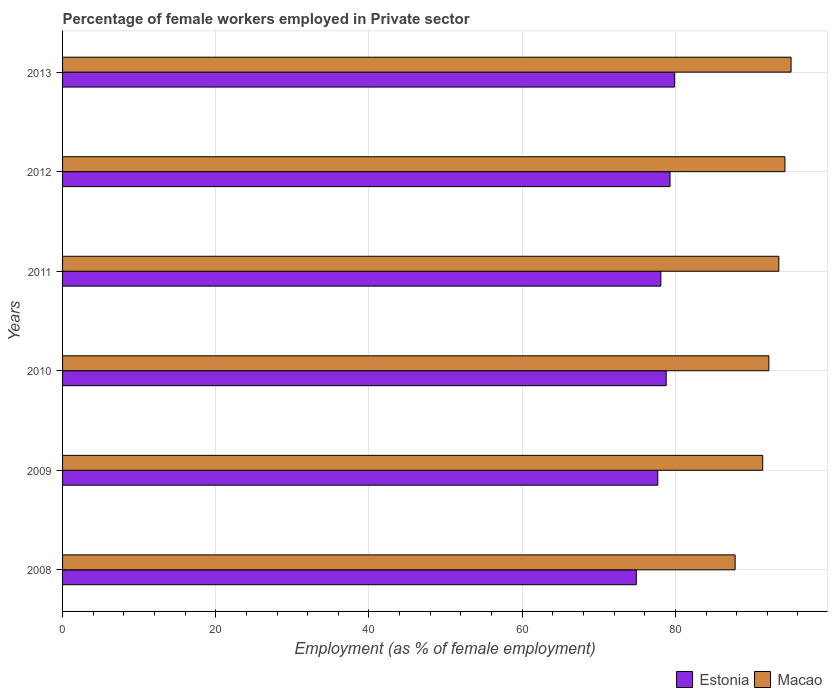How many different coloured bars are there?
Your answer should be compact. 2. Are the number of bars per tick equal to the number of legend labels?
Offer a very short reply. Yes. Are the number of bars on each tick of the Y-axis equal?
Provide a succinct answer. Yes. In how many cases, is the number of bars for a given year not equal to the number of legend labels?
Give a very brief answer. 0. What is the percentage of females employed in Private sector in Estonia in 2011?
Make the answer very short. 78.1. Across all years, what is the maximum percentage of females employed in Private sector in Estonia?
Provide a succinct answer. 79.9. Across all years, what is the minimum percentage of females employed in Private sector in Macao?
Keep it short and to the point. 87.8. In which year was the percentage of females employed in Private sector in Estonia maximum?
Your answer should be compact. 2013. What is the total percentage of females employed in Private sector in Macao in the graph?
Your answer should be very brief. 554.3. What is the difference between the percentage of females employed in Private sector in Estonia in 2009 and that in 2011?
Provide a succinct answer. -0.4. What is the difference between the percentage of females employed in Private sector in Estonia in 2013 and the percentage of females employed in Private sector in Macao in 2012?
Your answer should be very brief. -14.4. What is the average percentage of females employed in Private sector in Estonia per year?
Give a very brief answer. 78.12. In the year 2011, what is the difference between the percentage of females employed in Private sector in Macao and percentage of females employed in Private sector in Estonia?
Offer a terse response. 15.4. In how many years, is the percentage of females employed in Private sector in Macao greater than 28 %?
Provide a short and direct response. 6. What is the ratio of the percentage of females employed in Private sector in Macao in 2008 to that in 2011?
Provide a succinct answer. 0.94. What is the difference between the highest and the second highest percentage of females employed in Private sector in Estonia?
Offer a terse response. 0.6. What is the difference between the highest and the lowest percentage of females employed in Private sector in Estonia?
Your answer should be very brief. 5. In how many years, is the percentage of females employed in Private sector in Macao greater than the average percentage of females employed in Private sector in Macao taken over all years?
Your response must be concise. 3. Is the sum of the percentage of females employed in Private sector in Estonia in 2008 and 2009 greater than the maximum percentage of females employed in Private sector in Macao across all years?
Offer a very short reply. Yes. What does the 1st bar from the top in 2011 represents?
Your answer should be compact. Macao. What does the 1st bar from the bottom in 2009 represents?
Make the answer very short. Estonia. How many bars are there?
Make the answer very short. 12. Are all the bars in the graph horizontal?
Your response must be concise. Yes. What is the difference between two consecutive major ticks on the X-axis?
Offer a very short reply. 20. Does the graph contain grids?
Your answer should be very brief. Yes. What is the title of the graph?
Your response must be concise. Percentage of female workers employed in Private sector. What is the label or title of the X-axis?
Keep it short and to the point. Employment (as % of female employment). What is the Employment (as % of female employment) in Estonia in 2008?
Make the answer very short. 74.9. What is the Employment (as % of female employment) in Macao in 2008?
Offer a very short reply. 87.8. What is the Employment (as % of female employment) of Estonia in 2009?
Offer a terse response. 77.7. What is the Employment (as % of female employment) in Macao in 2009?
Ensure brevity in your answer.  91.4. What is the Employment (as % of female employment) of Estonia in 2010?
Ensure brevity in your answer.  78.8. What is the Employment (as % of female employment) in Macao in 2010?
Offer a terse response. 92.2. What is the Employment (as % of female employment) of Estonia in 2011?
Give a very brief answer. 78.1. What is the Employment (as % of female employment) in Macao in 2011?
Your response must be concise. 93.5. What is the Employment (as % of female employment) in Estonia in 2012?
Make the answer very short. 79.3. What is the Employment (as % of female employment) in Macao in 2012?
Make the answer very short. 94.3. What is the Employment (as % of female employment) in Estonia in 2013?
Provide a short and direct response. 79.9. What is the Employment (as % of female employment) of Macao in 2013?
Your answer should be compact. 95.1. Across all years, what is the maximum Employment (as % of female employment) in Estonia?
Your response must be concise. 79.9. Across all years, what is the maximum Employment (as % of female employment) in Macao?
Offer a very short reply. 95.1. Across all years, what is the minimum Employment (as % of female employment) of Estonia?
Make the answer very short. 74.9. Across all years, what is the minimum Employment (as % of female employment) of Macao?
Provide a succinct answer. 87.8. What is the total Employment (as % of female employment) in Estonia in the graph?
Your answer should be very brief. 468.7. What is the total Employment (as % of female employment) in Macao in the graph?
Offer a terse response. 554.3. What is the difference between the Employment (as % of female employment) of Estonia in 2008 and that in 2010?
Give a very brief answer. -3.9. What is the difference between the Employment (as % of female employment) in Estonia in 2008 and that in 2012?
Give a very brief answer. -4.4. What is the difference between the Employment (as % of female employment) of Macao in 2008 and that in 2012?
Your answer should be compact. -6.5. What is the difference between the Employment (as % of female employment) of Estonia in 2008 and that in 2013?
Your response must be concise. -5. What is the difference between the Employment (as % of female employment) of Estonia in 2009 and that in 2011?
Provide a succinct answer. -0.4. What is the difference between the Employment (as % of female employment) in Macao in 2009 and that in 2011?
Offer a terse response. -2.1. What is the difference between the Employment (as % of female employment) of Macao in 2009 and that in 2013?
Make the answer very short. -3.7. What is the difference between the Employment (as % of female employment) of Macao in 2010 and that in 2011?
Make the answer very short. -1.3. What is the difference between the Employment (as % of female employment) of Macao in 2010 and that in 2013?
Offer a very short reply. -2.9. What is the difference between the Employment (as % of female employment) in Macao in 2011 and that in 2012?
Keep it short and to the point. -0.8. What is the difference between the Employment (as % of female employment) in Estonia in 2012 and that in 2013?
Your answer should be very brief. -0.6. What is the difference between the Employment (as % of female employment) of Estonia in 2008 and the Employment (as % of female employment) of Macao in 2009?
Provide a succinct answer. -16.5. What is the difference between the Employment (as % of female employment) in Estonia in 2008 and the Employment (as % of female employment) in Macao in 2010?
Offer a very short reply. -17.3. What is the difference between the Employment (as % of female employment) of Estonia in 2008 and the Employment (as % of female employment) of Macao in 2011?
Offer a terse response. -18.6. What is the difference between the Employment (as % of female employment) in Estonia in 2008 and the Employment (as % of female employment) in Macao in 2012?
Give a very brief answer. -19.4. What is the difference between the Employment (as % of female employment) of Estonia in 2008 and the Employment (as % of female employment) of Macao in 2013?
Offer a terse response. -20.2. What is the difference between the Employment (as % of female employment) of Estonia in 2009 and the Employment (as % of female employment) of Macao in 2010?
Your answer should be compact. -14.5. What is the difference between the Employment (as % of female employment) of Estonia in 2009 and the Employment (as % of female employment) of Macao in 2011?
Make the answer very short. -15.8. What is the difference between the Employment (as % of female employment) in Estonia in 2009 and the Employment (as % of female employment) in Macao in 2012?
Make the answer very short. -16.6. What is the difference between the Employment (as % of female employment) of Estonia in 2009 and the Employment (as % of female employment) of Macao in 2013?
Keep it short and to the point. -17.4. What is the difference between the Employment (as % of female employment) in Estonia in 2010 and the Employment (as % of female employment) in Macao in 2011?
Offer a terse response. -14.7. What is the difference between the Employment (as % of female employment) in Estonia in 2010 and the Employment (as % of female employment) in Macao in 2012?
Provide a succinct answer. -15.5. What is the difference between the Employment (as % of female employment) in Estonia in 2010 and the Employment (as % of female employment) in Macao in 2013?
Your answer should be compact. -16.3. What is the difference between the Employment (as % of female employment) in Estonia in 2011 and the Employment (as % of female employment) in Macao in 2012?
Provide a succinct answer. -16.2. What is the difference between the Employment (as % of female employment) in Estonia in 2012 and the Employment (as % of female employment) in Macao in 2013?
Offer a very short reply. -15.8. What is the average Employment (as % of female employment) of Estonia per year?
Keep it short and to the point. 78.12. What is the average Employment (as % of female employment) in Macao per year?
Keep it short and to the point. 92.38. In the year 2009, what is the difference between the Employment (as % of female employment) in Estonia and Employment (as % of female employment) in Macao?
Provide a short and direct response. -13.7. In the year 2010, what is the difference between the Employment (as % of female employment) of Estonia and Employment (as % of female employment) of Macao?
Offer a very short reply. -13.4. In the year 2011, what is the difference between the Employment (as % of female employment) of Estonia and Employment (as % of female employment) of Macao?
Offer a very short reply. -15.4. In the year 2013, what is the difference between the Employment (as % of female employment) in Estonia and Employment (as % of female employment) in Macao?
Your answer should be compact. -15.2. What is the ratio of the Employment (as % of female employment) of Macao in 2008 to that in 2009?
Your answer should be compact. 0.96. What is the ratio of the Employment (as % of female employment) of Estonia in 2008 to that in 2010?
Offer a very short reply. 0.95. What is the ratio of the Employment (as % of female employment) in Macao in 2008 to that in 2010?
Provide a succinct answer. 0.95. What is the ratio of the Employment (as % of female employment) in Estonia in 2008 to that in 2011?
Keep it short and to the point. 0.96. What is the ratio of the Employment (as % of female employment) of Macao in 2008 to that in 2011?
Your answer should be very brief. 0.94. What is the ratio of the Employment (as % of female employment) of Estonia in 2008 to that in 2012?
Keep it short and to the point. 0.94. What is the ratio of the Employment (as % of female employment) in Macao in 2008 to that in 2012?
Make the answer very short. 0.93. What is the ratio of the Employment (as % of female employment) in Estonia in 2008 to that in 2013?
Provide a short and direct response. 0.94. What is the ratio of the Employment (as % of female employment) of Macao in 2008 to that in 2013?
Provide a short and direct response. 0.92. What is the ratio of the Employment (as % of female employment) in Macao in 2009 to that in 2010?
Your answer should be very brief. 0.99. What is the ratio of the Employment (as % of female employment) in Estonia in 2009 to that in 2011?
Ensure brevity in your answer.  0.99. What is the ratio of the Employment (as % of female employment) in Macao in 2009 to that in 2011?
Provide a short and direct response. 0.98. What is the ratio of the Employment (as % of female employment) of Estonia in 2009 to that in 2012?
Your response must be concise. 0.98. What is the ratio of the Employment (as % of female employment) in Macao in 2009 to that in 2012?
Provide a succinct answer. 0.97. What is the ratio of the Employment (as % of female employment) in Estonia in 2009 to that in 2013?
Your answer should be very brief. 0.97. What is the ratio of the Employment (as % of female employment) in Macao in 2009 to that in 2013?
Give a very brief answer. 0.96. What is the ratio of the Employment (as % of female employment) of Macao in 2010 to that in 2011?
Offer a very short reply. 0.99. What is the ratio of the Employment (as % of female employment) of Macao in 2010 to that in 2012?
Ensure brevity in your answer.  0.98. What is the ratio of the Employment (as % of female employment) in Estonia in 2010 to that in 2013?
Offer a terse response. 0.99. What is the ratio of the Employment (as % of female employment) in Macao in 2010 to that in 2013?
Your answer should be compact. 0.97. What is the ratio of the Employment (as % of female employment) in Estonia in 2011 to that in 2012?
Your answer should be very brief. 0.98. What is the ratio of the Employment (as % of female employment) in Estonia in 2011 to that in 2013?
Offer a terse response. 0.98. What is the ratio of the Employment (as % of female employment) in Macao in 2011 to that in 2013?
Give a very brief answer. 0.98. What is the ratio of the Employment (as % of female employment) of Macao in 2012 to that in 2013?
Ensure brevity in your answer.  0.99. What is the difference between the highest and the second highest Employment (as % of female employment) of Estonia?
Make the answer very short. 0.6. What is the difference between the highest and the second highest Employment (as % of female employment) of Macao?
Provide a short and direct response. 0.8. What is the difference between the highest and the lowest Employment (as % of female employment) in Estonia?
Provide a succinct answer. 5. 